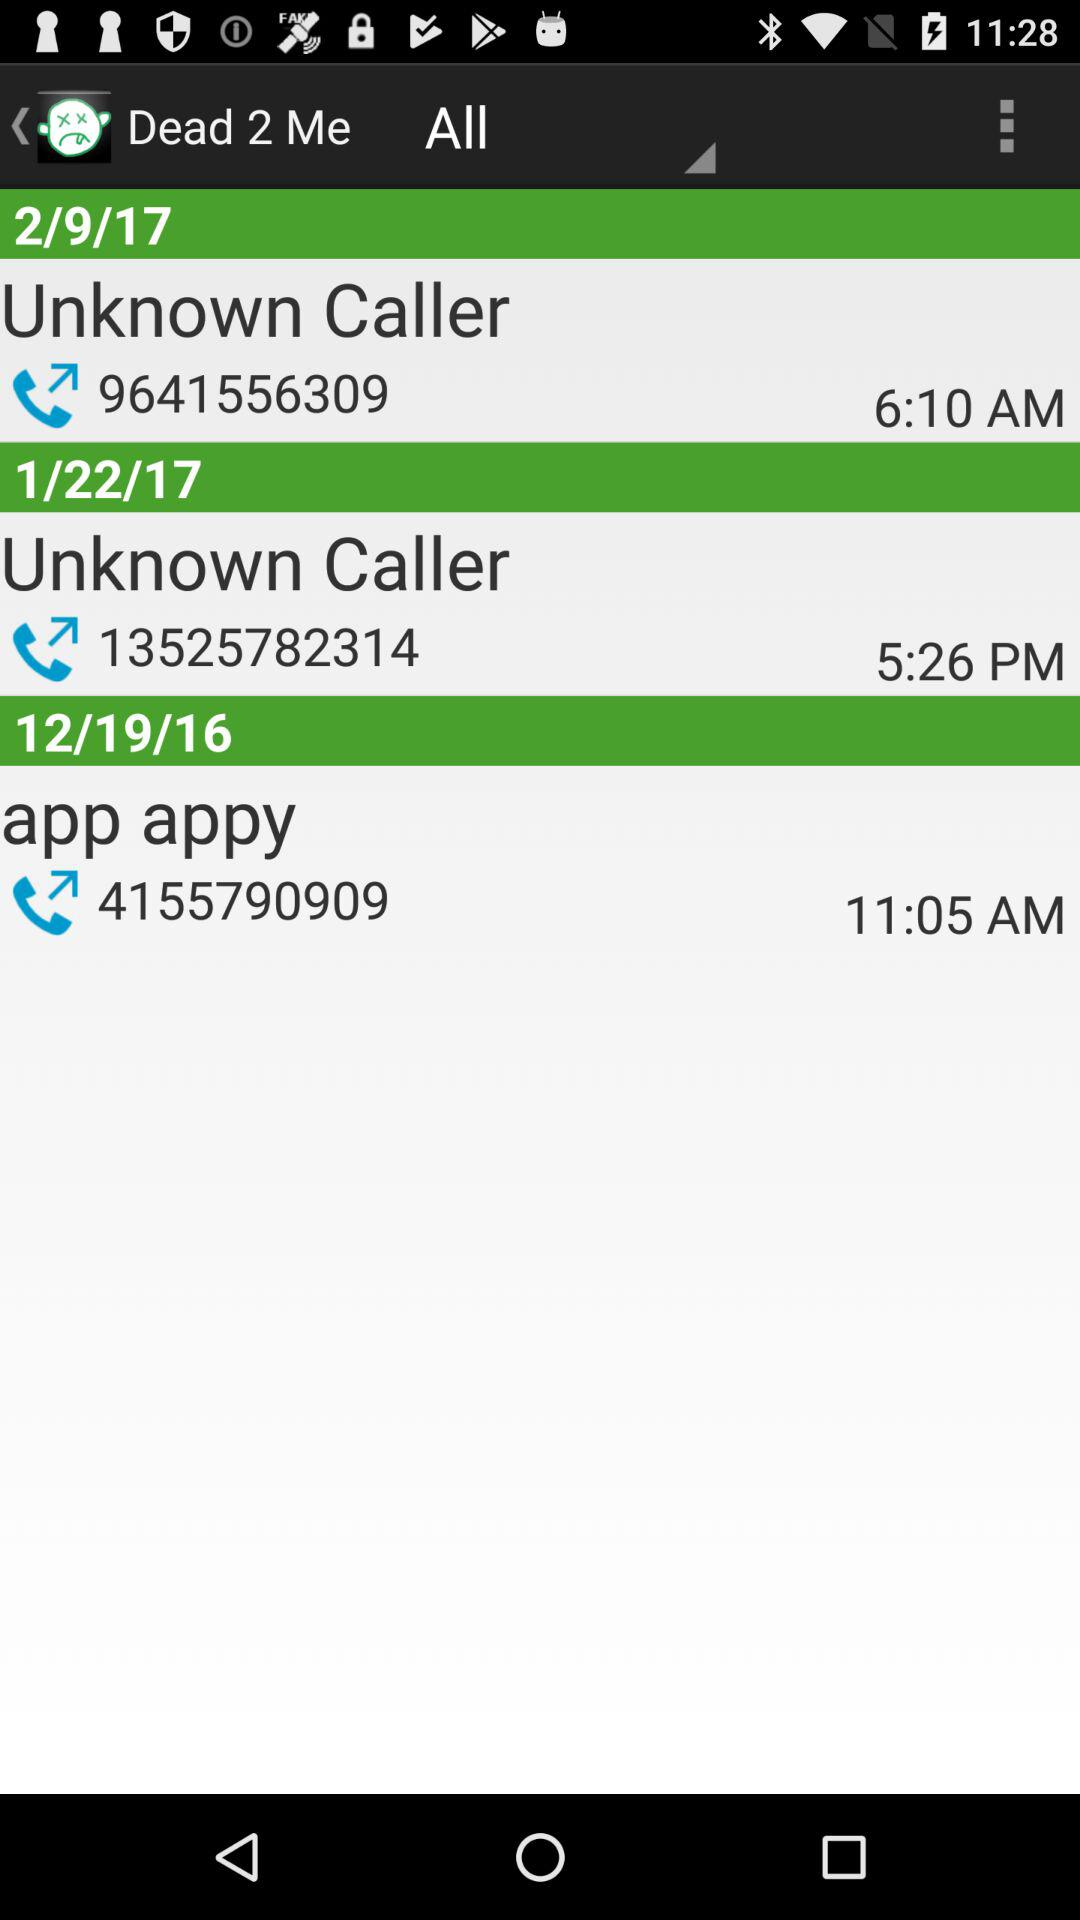What is the number of "app appy"? The number is 4155790909. 